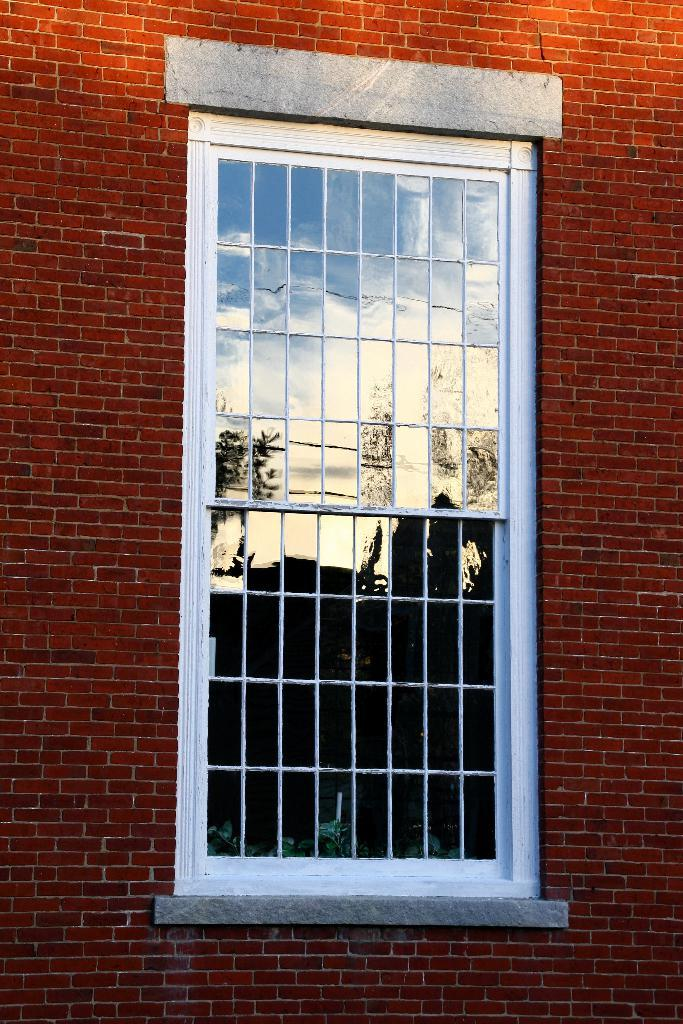What type of structure is visible in the image? There is a brick wall in the image. Can you describe any openings or features in the brick wall? Yes, there is a window in the brick wall. Where is the nest of birds located in the image? There is no nest of birds present in the image. Can you see any basketballs or balls in the image? There are no basketballs or balls visible in the image. 